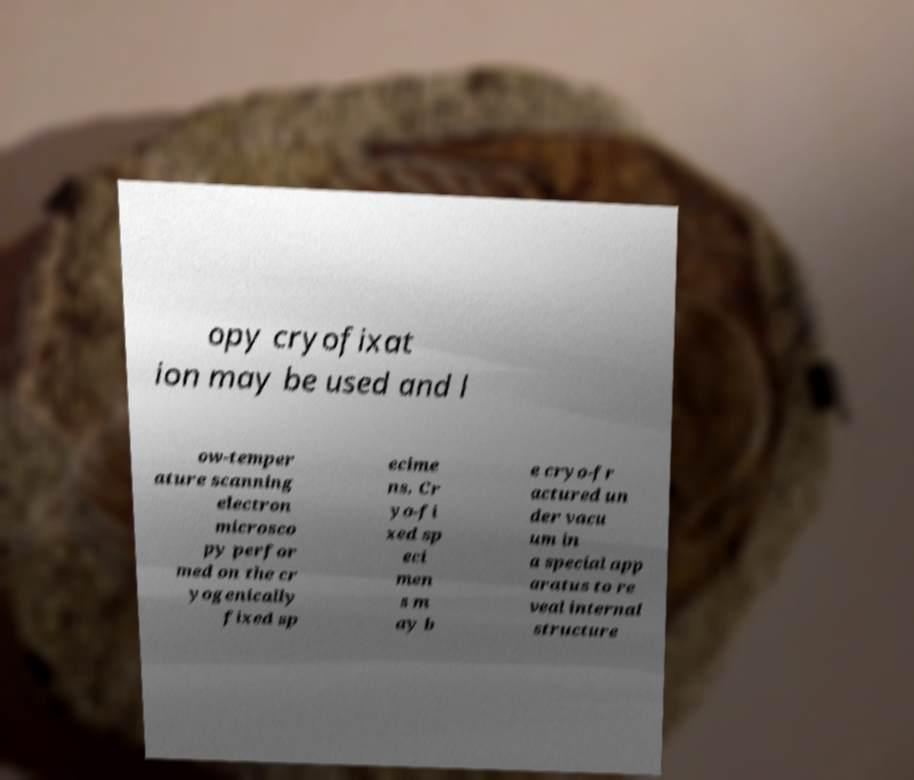Please identify and transcribe the text found in this image. opy cryofixat ion may be used and l ow-temper ature scanning electron microsco py perfor med on the cr yogenically fixed sp ecime ns. Cr yo-fi xed sp eci men s m ay b e cryo-fr actured un der vacu um in a special app aratus to re veal internal structure 